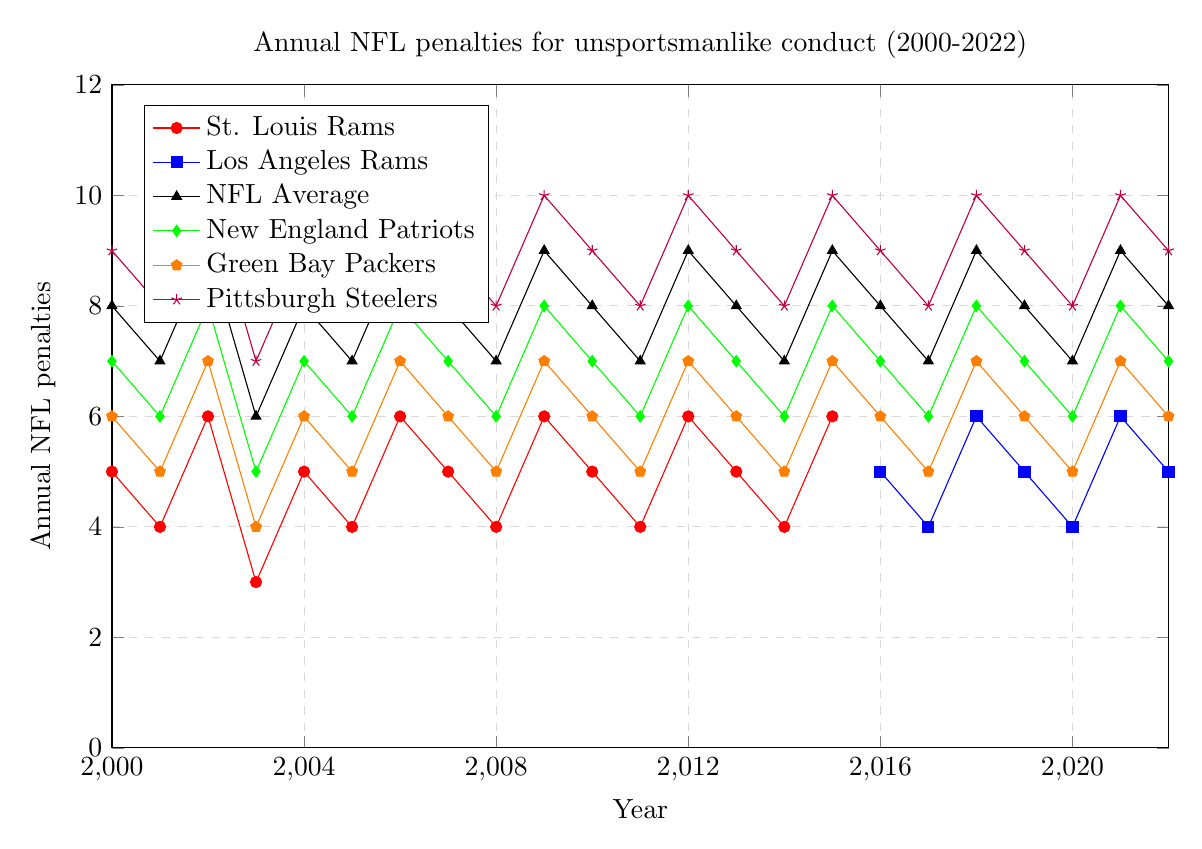What year did the St. Louis Rams have the highest number of penalties for unsportsmanlike conduct? By looking at the line for the St. Louis Rams, the highest point corresponds to the number of penalties. The peak is in 2002 and 2006 with 6 penalties each.
Answer: 2002 and 2006 How many penalties did the Los Angeles Rams have in 2016? Locate the year 2016 on the x-axis and check the point corresponding to the Los Angeles Rams line. In 2016, the Los Angeles Rams line intersects at 5 penalties.
Answer: 5 Which team had more penalties in 2018, the Los Angeles Rams or the Green Bay Packers? Compare the points for the Los Angeles Rams and the Green Bay Packers in the year 2018. The Los Angeles Rams had 6 penalties, while the Green Bay Packers had 7 penalties.
Answer: Green Bay Packers From 2010 to 2015, what is the average number of penalties for the St. Louis Rams? Identify the points for the St. Louis Rams from 2010 to 2015, sum these values (5 + 4 + 6 + 5 + 4 + 6) = 30, and divide by 6 (the number of years) to get the average.
Answer: 5 Which team had the highest number of penalties for unsportsmanlike conduct throughout the entire timeline, and in what year? Examine all the lines to find the highest point. The Pittsburgh Steelers had the highest number of penalties, reaching 10 in multiple years (2002, 2006, 2009, 2012, 2015, 2018, and 2021).
Answer: Pittsburgh Steelers, multiple years How did the number of penalties for the New England Patriots change from 2000 to 2022? Track the New England Patriots' line from 2000 to 2022 and describe the trend. The values fluctuate but are generally between 5 and 8, with years at 8 indicating a peak.
Answer: Fluctuated between 5 and 8 Which team showed the most consistent trend in penalties, and what was the general range? Evaluate the smoothness of each team's line. The St. Louis Rams show a relatively consistent trend with penalties ranging from 3 to 6
Answer: St. Louis Rams, 3-6 Compare the penalties of the Pittsburgh Steelers and the NFL Average in 2020. Which was higher and by how much? Check both values on the y-axis for the year 2020. Pittsburgh Steelers had 8 penalties, while the NFL Average had 7. The Steelers had 1 more penalty than the NFL Average.
Answer: Pittsburgh Steelers, 1 